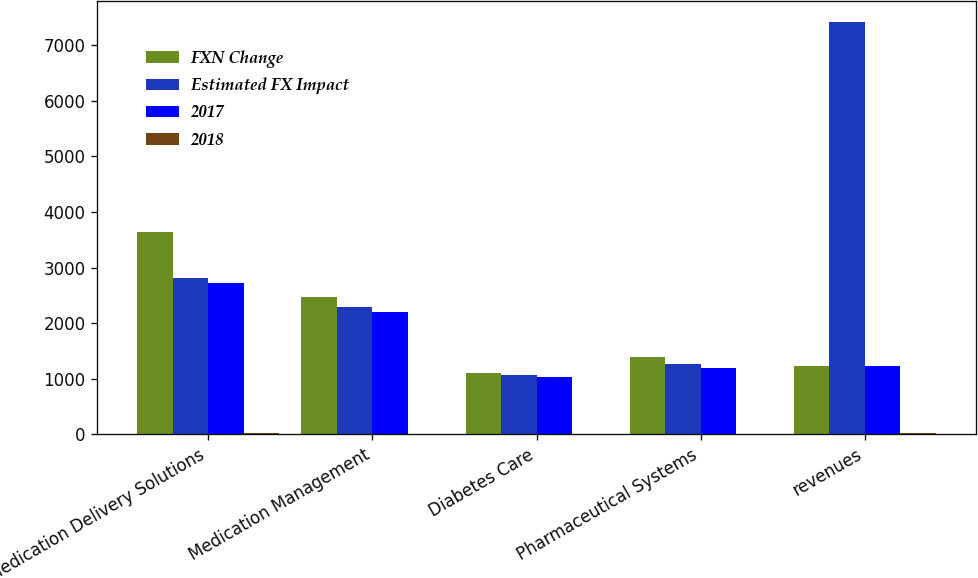<chart> <loc_0><loc_0><loc_500><loc_500><stacked_bar_chart><ecel><fcel>Medication Delivery Solutions<fcel>Medication Management<fcel>Diabetes Care<fcel>Pharmaceutical Systems<fcel>revenues<nl><fcel>FXN Change<fcel>3644<fcel>2470<fcel>1105<fcel>1397<fcel>1227.5<nl><fcel>Estimated FX Impact<fcel>2812<fcel>2295<fcel>1056<fcel>1256<fcel>7419<nl><fcel>2017<fcel>2724<fcel>2197<fcel>1023<fcel>1199<fcel>1227.5<nl><fcel>2018<fcel>29.6<fcel>7.7<fcel>4.6<fcel>11.2<fcel>16.1<nl></chart> 